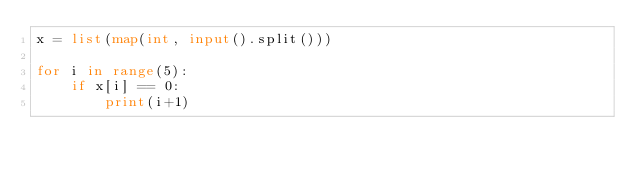Convert code to text. <code><loc_0><loc_0><loc_500><loc_500><_Python_>x = list(map(int, input().split()))

for i in range(5):
    if x[i] == 0:
        print(i+1)
</code> 